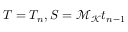Convert formula to latex. <formula><loc_0><loc_0><loc_500><loc_500>T = T _ { n } , S = \mathcal { M } _ { \mathcal { K } } t _ { n - 1 }</formula> 